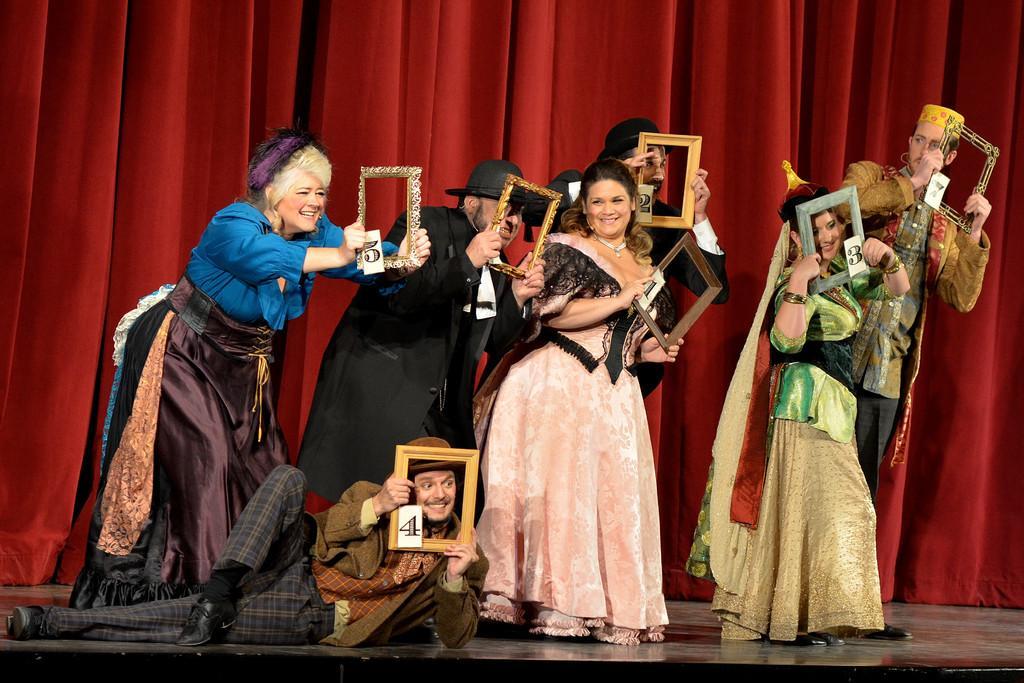How would you summarize this image in a sentence or two? In this picture I can see few persons who are on the stage and I see that all of them are holding frames in their hands and the man on the left is lying on the floor. In the background I can see the red color curtains. 